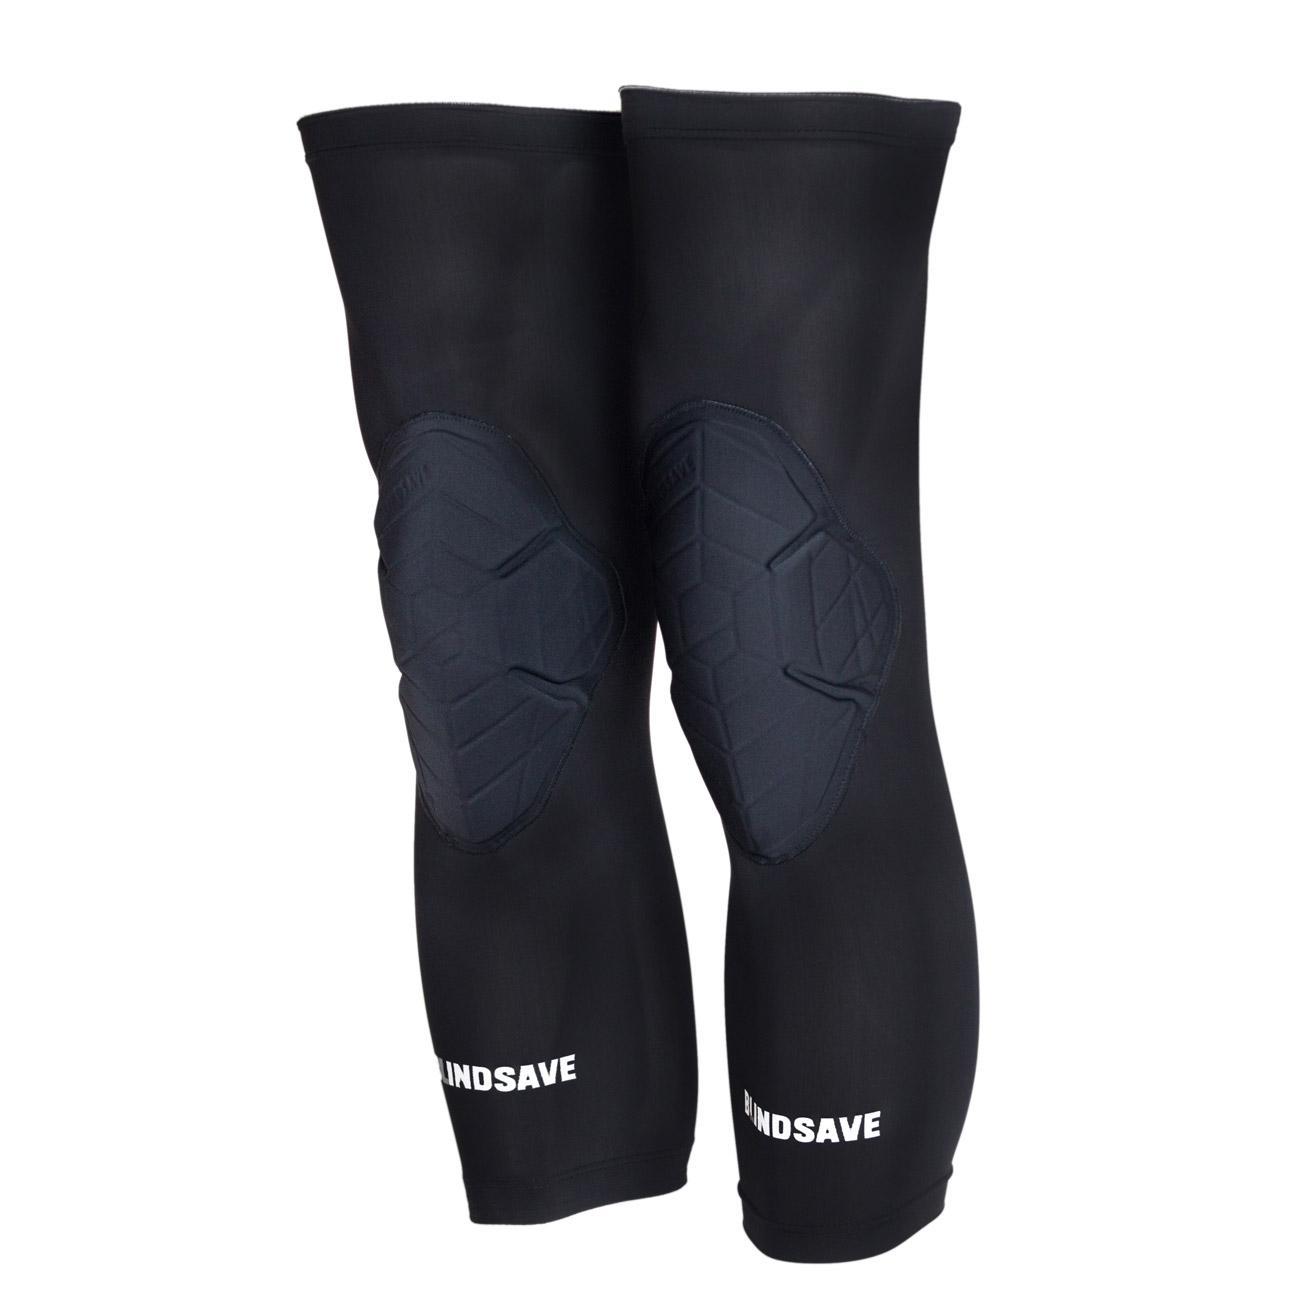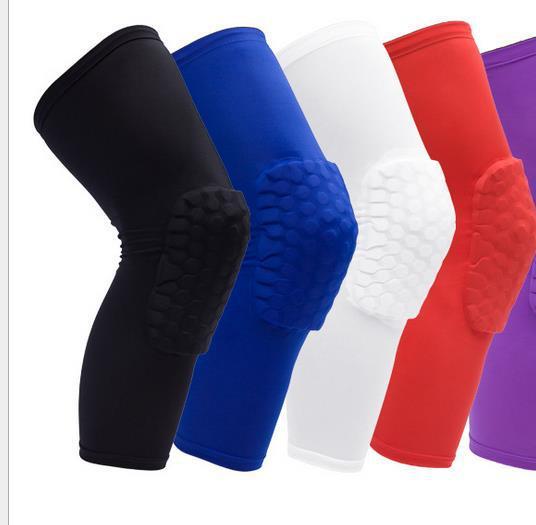The first image is the image on the left, the second image is the image on the right. Assess this claim about the two images: "Eight compression socks with knee pads are visible.". Correct or not? Answer yes or no. No. 